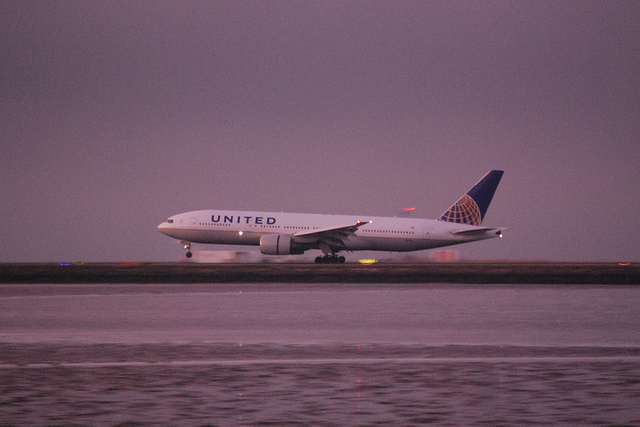<image>What country does this plane hail from? I don't know what country the plane hails from. It could possibly be from United States or America. What country does this plane hail from? I don't know what country does this plane hail from. It can be from the US or America. 